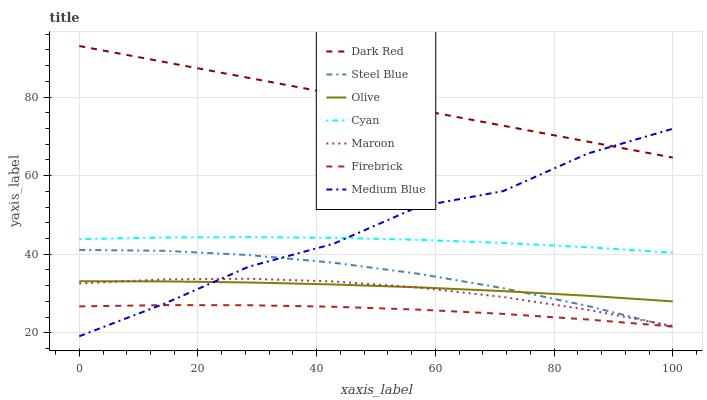Does Firebrick have the minimum area under the curve?
Answer yes or no. Yes. Does Dark Red have the maximum area under the curve?
Answer yes or no. Yes. Does Medium Blue have the minimum area under the curve?
Answer yes or no. No. Does Medium Blue have the maximum area under the curve?
Answer yes or no. No. Is Dark Red the smoothest?
Answer yes or no. Yes. Is Medium Blue the roughest?
Answer yes or no. Yes. Is Firebrick the smoothest?
Answer yes or no. No. Is Firebrick the roughest?
Answer yes or no. No. Does Medium Blue have the lowest value?
Answer yes or no. Yes. Does Firebrick have the lowest value?
Answer yes or no. No. Does Dark Red have the highest value?
Answer yes or no. Yes. Does Medium Blue have the highest value?
Answer yes or no. No. Is Olive less than Cyan?
Answer yes or no. Yes. Is Dark Red greater than Maroon?
Answer yes or no. Yes. Does Firebrick intersect Steel Blue?
Answer yes or no. Yes. Is Firebrick less than Steel Blue?
Answer yes or no. No. Is Firebrick greater than Steel Blue?
Answer yes or no. No. Does Olive intersect Cyan?
Answer yes or no. No. 